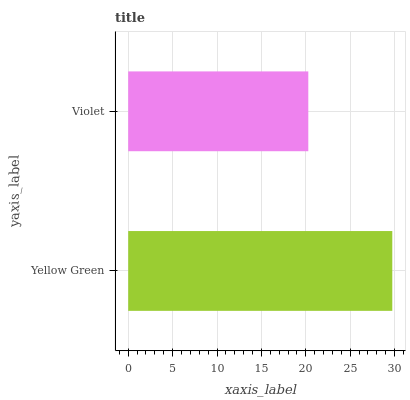Is Violet the minimum?
Answer yes or no. Yes. Is Yellow Green the maximum?
Answer yes or no. Yes. Is Violet the maximum?
Answer yes or no. No. Is Yellow Green greater than Violet?
Answer yes or no. Yes. Is Violet less than Yellow Green?
Answer yes or no. Yes. Is Violet greater than Yellow Green?
Answer yes or no. No. Is Yellow Green less than Violet?
Answer yes or no. No. Is Yellow Green the high median?
Answer yes or no. Yes. Is Violet the low median?
Answer yes or no. Yes. Is Violet the high median?
Answer yes or no. No. Is Yellow Green the low median?
Answer yes or no. No. 